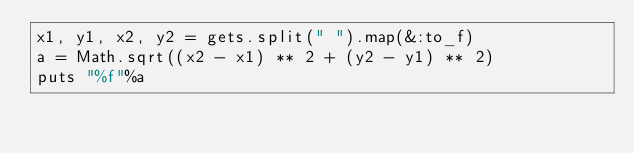<code> <loc_0><loc_0><loc_500><loc_500><_Ruby_>x1, y1, x2, y2 = gets.split(" ").map(&:to_f)
a = Math.sqrt((x2 - x1) ** 2 + (y2 - y1) ** 2)
puts "%f"%a</code> 